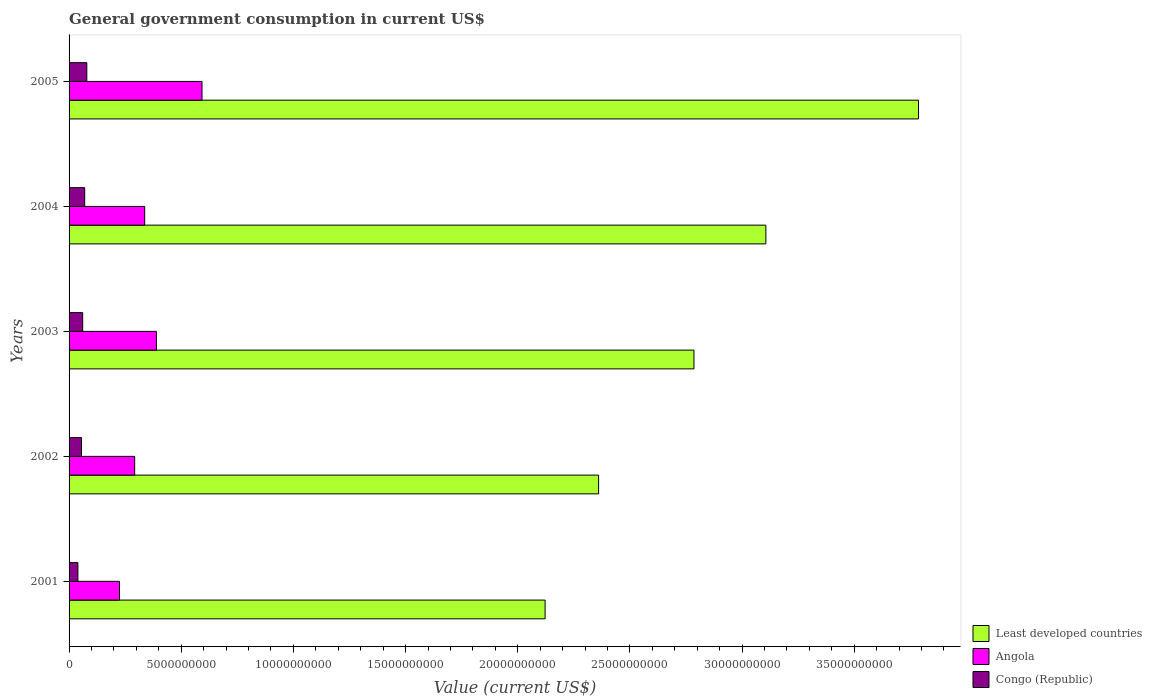How many different coloured bars are there?
Make the answer very short. 3. How many groups of bars are there?
Keep it short and to the point. 5. Are the number of bars per tick equal to the number of legend labels?
Keep it short and to the point. Yes. What is the government conusmption in Least developed countries in 2001?
Offer a terse response. 2.12e+1. Across all years, what is the maximum government conusmption in Congo (Republic)?
Provide a succinct answer. 7.91e+08. Across all years, what is the minimum government conusmption in Congo (Republic)?
Provide a succinct answer. 3.94e+08. In which year was the government conusmption in Least developed countries maximum?
Ensure brevity in your answer.  2005. What is the total government conusmption in Least developed countries in the graph?
Keep it short and to the point. 1.42e+11. What is the difference between the government conusmption in Congo (Republic) in 2001 and that in 2003?
Offer a terse response. -2.13e+08. What is the difference between the government conusmption in Angola in 2004 and the government conusmption in Congo (Republic) in 2003?
Offer a terse response. 2.76e+09. What is the average government conusmption in Least developed countries per year?
Provide a succinct answer. 2.83e+1. In the year 2002, what is the difference between the government conusmption in Congo (Republic) and government conusmption in Least developed countries?
Provide a short and direct response. -2.31e+1. What is the ratio of the government conusmption in Angola in 2003 to that in 2005?
Your answer should be compact. 0.66. Is the government conusmption in Least developed countries in 2003 less than that in 2005?
Your response must be concise. Yes. What is the difference between the highest and the second highest government conusmption in Angola?
Your answer should be very brief. 2.03e+09. What is the difference between the highest and the lowest government conusmption in Angola?
Give a very brief answer. 3.68e+09. What does the 2nd bar from the top in 2001 represents?
Provide a short and direct response. Angola. What does the 1st bar from the bottom in 2005 represents?
Provide a short and direct response. Least developed countries. How many years are there in the graph?
Provide a short and direct response. 5. Where does the legend appear in the graph?
Offer a terse response. Bottom right. How many legend labels are there?
Offer a terse response. 3. How are the legend labels stacked?
Ensure brevity in your answer.  Vertical. What is the title of the graph?
Give a very brief answer. General government consumption in current US$. Does "Turkey" appear as one of the legend labels in the graph?
Offer a terse response. No. What is the label or title of the X-axis?
Your response must be concise. Value (current US$). What is the label or title of the Y-axis?
Provide a short and direct response. Years. What is the Value (current US$) in Least developed countries in 2001?
Make the answer very short. 2.12e+1. What is the Value (current US$) of Angola in 2001?
Give a very brief answer. 2.25e+09. What is the Value (current US$) of Congo (Republic) in 2001?
Your answer should be very brief. 3.94e+08. What is the Value (current US$) in Least developed countries in 2002?
Make the answer very short. 2.36e+1. What is the Value (current US$) in Angola in 2002?
Give a very brief answer. 2.92e+09. What is the Value (current US$) in Congo (Republic) in 2002?
Provide a succinct answer. 5.54e+08. What is the Value (current US$) in Least developed countries in 2003?
Provide a succinct answer. 2.79e+1. What is the Value (current US$) in Angola in 2003?
Keep it short and to the point. 3.89e+09. What is the Value (current US$) in Congo (Republic) in 2003?
Offer a terse response. 6.07e+08. What is the Value (current US$) in Least developed countries in 2004?
Offer a very short reply. 3.11e+1. What is the Value (current US$) in Angola in 2004?
Ensure brevity in your answer.  3.37e+09. What is the Value (current US$) in Congo (Republic) in 2004?
Make the answer very short. 6.96e+08. What is the Value (current US$) in Least developed countries in 2005?
Provide a short and direct response. 3.79e+1. What is the Value (current US$) of Angola in 2005?
Your answer should be compact. 5.93e+09. What is the Value (current US$) of Congo (Republic) in 2005?
Provide a short and direct response. 7.91e+08. Across all years, what is the maximum Value (current US$) of Least developed countries?
Provide a succinct answer. 3.79e+1. Across all years, what is the maximum Value (current US$) of Angola?
Keep it short and to the point. 5.93e+09. Across all years, what is the maximum Value (current US$) in Congo (Republic)?
Provide a succinct answer. 7.91e+08. Across all years, what is the minimum Value (current US$) in Least developed countries?
Ensure brevity in your answer.  2.12e+1. Across all years, what is the minimum Value (current US$) in Angola?
Keep it short and to the point. 2.25e+09. Across all years, what is the minimum Value (current US$) of Congo (Republic)?
Offer a terse response. 3.94e+08. What is the total Value (current US$) of Least developed countries in the graph?
Offer a terse response. 1.42e+11. What is the total Value (current US$) of Angola in the graph?
Your answer should be very brief. 1.84e+1. What is the total Value (current US$) in Congo (Republic) in the graph?
Offer a very short reply. 3.04e+09. What is the difference between the Value (current US$) of Least developed countries in 2001 and that in 2002?
Ensure brevity in your answer.  -2.38e+09. What is the difference between the Value (current US$) in Angola in 2001 and that in 2002?
Your answer should be very brief. -6.76e+08. What is the difference between the Value (current US$) in Congo (Republic) in 2001 and that in 2002?
Your answer should be very brief. -1.61e+08. What is the difference between the Value (current US$) in Least developed countries in 2001 and that in 2003?
Offer a very short reply. -6.64e+09. What is the difference between the Value (current US$) of Angola in 2001 and that in 2003?
Your answer should be very brief. -1.65e+09. What is the difference between the Value (current US$) of Congo (Republic) in 2001 and that in 2003?
Offer a terse response. -2.13e+08. What is the difference between the Value (current US$) in Least developed countries in 2001 and that in 2004?
Ensure brevity in your answer.  -9.84e+09. What is the difference between the Value (current US$) of Angola in 2001 and that in 2004?
Your answer should be compact. -1.12e+09. What is the difference between the Value (current US$) of Congo (Republic) in 2001 and that in 2004?
Provide a succinct answer. -3.02e+08. What is the difference between the Value (current US$) of Least developed countries in 2001 and that in 2005?
Keep it short and to the point. -1.66e+1. What is the difference between the Value (current US$) in Angola in 2001 and that in 2005?
Keep it short and to the point. -3.68e+09. What is the difference between the Value (current US$) in Congo (Republic) in 2001 and that in 2005?
Provide a short and direct response. -3.97e+08. What is the difference between the Value (current US$) of Least developed countries in 2002 and that in 2003?
Your answer should be very brief. -4.25e+09. What is the difference between the Value (current US$) of Angola in 2002 and that in 2003?
Provide a succinct answer. -9.69e+08. What is the difference between the Value (current US$) in Congo (Republic) in 2002 and that in 2003?
Your response must be concise. -5.25e+07. What is the difference between the Value (current US$) of Least developed countries in 2002 and that in 2004?
Provide a succinct answer. -7.46e+09. What is the difference between the Value (current US$) in Angola in 2002 and that in 2004?
Ensure brevity in your answer.  -4.47e+08. What is the difference between the Value (current US$) of Congo (Republic) in 2002 and that in 2004?
Offer a very short reply. -1.42e+08. What is the difference between the Value (current US$) of Least developed countries in 2002 and that in 2005?
Ensure brevity in your answer.  -1.43e+1. What is the difference between the Value (current US$) in Angola in 2002 and that in 2005?
Offer a terse response. -3.00e+09. What is the difference between the Value (current US$) of Congo (Republic) in 2002 and that in 2005?
Your answer should be very brief. -2.37e+08. What is the difference between the Value (current US$) in Least developed countries in 2003 and that in 2004?
Your answer should be very brief. -3.21e+09. What is the difference between the Value (current US$) of Angola in 2003 and that in 2004?
Offer a very short reply. 5.22e+08. What is the difference between the Value (current US$) of Congo (Republic) in 2003 and that in 2004?
Give a very brief answer. -8.92e+07. What is the difference between the Value (current US$) of Least developed countries in 2003 and that in 2005?
Ensure brevity in your answer.  -1.00e+1. What is the difference between the Value (current US$) in Angola in 2003 and that in 2005?
Keep it short and to the point. -2.03e+09. What is the difference between the Value (current US$) in Congo (Republic) in 2003 and that in 2005?
Give a very brief answer. -1.84e+08. What is the difference between the Value (current US$) of Least developed countries in 2004 and that in 2005?
Offer a terse response. -6.80e+09. What is the difference between the Value (current US$) of Angola in 2004 and that in 2005?
Make the answer very short. -2.56e+09. What is the difference between the Value (current US$) of Congo (Republic) in 2004 and that in 2005?
Your answer should be compact. -9.49e+07. What is the difference between the Value (current US$) of Least developed countries in 2001 and the Value (current US$) of Angola in 2002?
Give a very brief answer. 1.83e+1. What is the difference between the Value (current US$) of Least developed countries in 2001 and the Value (current US$) of Congo (Republic) in 2002?
Your answer should be compact. 2.07e+1. What is the difference between the Value (current US$) of Angola in 2001 and the Value (current US$) of Congo (Republic) in 2002?
Your answer should be compact. 1.69e+09. What is the difference between the Value (current US$) in Least developed countries in 2001 and the Value (current US$) in Angola in 2003?
Offer a very short reply. 1.73e+1. What is the difference between the Value (current US$) of Least developed countries in 2001 and the Value (current US$) of Congo (Republic) in 2003?
Your response must be concise. 2.06e+1. What is the difference between the Value (current US$) in Angola in 2001 and the Value (current US$) in Congo (Republic) in 2003?
Your response must be concise. 1.64e+09. What is the difference between the Value (current US$) in Least developed countries in 2001 and the Value (current US$) in Angola in 2004?
Make the answer very short. 1.78e+1. What is the difference between the Value (current US$) of Least developed countries in 2001 and the Value (current US$) of Congo (Republic) in 2004?
Make the answer very short. 2.05e+1. What is the difference between the Value (current US$) of Angola in 2001 and the Value (current US$) of Congo (Republic) in 2004?
Your answer should be very brief. 1.55e+09. What is the difference between the Value (current US$) of Least developed countries in 2001 and the Value (current US$) of Angola in 2005?
Ensure brevity in your answer.  1.53e+1. What is the difference between the Value (current US$) of Least developed countries in 2001 and the Value (current US$) of Congo (Republic) in 2005?
Provide a short and direct response. 2.04e+1. What is the difference between the Value (current US$) of Angola in 2001 and the Value (current US$) of Congo (Republic) in 2005?
Give a very brief answer. 1.46e+09. What is the difference between the Value (current US$) of Least developed countries in 2002 and the Value (current US$) of Angola in 2003?
Your response must be concise. 1.97e+1. What is the difference between the Value (current US$) of Least developed countries in 2002 and the Value (current US$) of Congo (Republic) in 2003?
Offer a terse response. 2.30e+1. What is the difference between the Value (current US$) of Angola in 2002 and the Value (current US$) of Congo (Republic) in 2003?
Give a very brief answer. 2.32e+09. What is the difference between the Value (current US$) of Least developed countries in 2002 and the Value (current US$) of Angola in 2004?
Your answer should be very brief. 2.02e+1. What is the difference between the Value (current US$) in Least developed countries in 2002 and the Value (current US$) in Congo (Republic) in 2004?
Keep it short and to the point. 2.29e+1. What is the difference between the Value (current US$) in Angola in 2002 and the Value (current US$) in Congo (Republic) in 2004?
Offer a very short reply. 2.23e+09. What is the difference between the Value (current US$) of Least developed countries in 2002 and the Value (current US$) of Angola in 2005?
Provide a succinct answer. 1.77e+1. What is the difference between the Value (current US$) of Least developed countries in 2002 and the Value (current US$) of Congo (Republic) in 2005?
Your answer should be very brief. 2.28e+1. What is the difference between the Value (current US$) of Angola in 2002 and the Value (current US$) of Congo (Republic) in 2005?
Your answer should be very brief. 2.13e+09. What is the difference between the Value (current US$) in Least developed countries in 2003 and the Value (current US$) in Angola in 2004?
Your response must be concise. 2.45e+1. What is the difference between the Value (current US$) of Least developed countries in 2003 and the Value (current US$) of Congo (Republic) in 2004?
Give a very brief answer. 2.72e+1. What is the difference between the Value (current US$) of Angola in 2003 and the Value (current US$) of Congo (Republic) in 2004?
Ensure brevity in your answer.  3.20e+09. What is the difference between the Value (current US$) in Least developed countries in 2003 and the Value (current US$) in Angola in 2005?
Provide a succinct answer. 2.19e+1. What is the difference between the Value (current US$) of Least developed countries in 2003 and the Value (current US$) of Congo (Republic) in 2005?
Make the answer very short. 2.71e+1. What is the difference between the Value (current US$) of Angola in 2003 and the Value (current US$) of Congo (Republic) in 2005?
Your answer should be compact. 3.10e+09. What is the difference between the Value (current US$) of Least developed countries in 2004 and the Value (current US$) of Angola in 2005?
Ensure brevity in your answer.  2.51e+1. What is the difference between the Value (current US$) of Least developed countries in 2004 and the Value (current US$) of Congo (Republic) in 2005?
Keep it short and to the point. 3.03e+1. What is the difference between the Value (current US$) of Angola in 2004 and the Value (current US$) of Congo (Republic) in 2005?
Ensure brevity in your answer.  2.58e+09. What is the average Value (current US$) in Least developed countries per year?
Ensure brevity in your answer.  2.83e+1. What is the average Value (current US$) in Angola per year?
Ensure brevity in your answer.  3.67e+09. What is the average Value (current US$) of Congo (Republic) per year?
Offer a terse response. 6.08e+08. In the year 2001, what is the difference between the Value (current US$) of Least developed countries and Value (current US$) of Angola?
Ensure brevity in your answer.  1.90e+1. In the year 2001, what is the difference between the Value (current US$) of Least developed countries and Value (current US$) of Congo (Republic)?
Offer a terse response. 2.08e+1. In the year 2001, what is the difference between the Value (current US$) of Angola and Value (current US$) of Congo (Republic)?
Keep it short and to the point. 1.85e+09. In the year 2002, what is the difference between the Value (current US$) of Least developed countries and Value (current US$) of Angola?
Your answer should be compact. 2.07e+1. In the year 2002, what is the difference between the Value (current US$) in Least developed countries and Value (current US$) in Congo (Republic)?
Ensure brevity in your answer.  2.31e+1. In the year 2002, what is the difference between the Value (current US$) in Angola and Value (current US$) in Congo (Republic)?
Provide a short and direct response. 2.37e+09. In the year 2003, what is the difference between the Value (current US$) of Least developed countries and Value (current US$) of Angola?
Offer a terse response. 2.40e+1. In the year 2003, what is the difference between the Value (current US$) in Least developed countries and Value (current US$) in Congo (Republic)?
Your answer should be very brief. 2.72e+1. In the year 2003, what is the difference between the Value (current US$) of Angola and Value (current US$) of Congo (Republic)?
Offer a terse response. 3.29e+09. In the year 2004, what is the difference between the Value (current US$) in Least developed countries and Value (current US$) in Angola?
Your answer should be compact. 2.77e+1. In the year 2004, what is the difference between the Value (current US$) in Least developed countries and Value (current US$) in Congo (Republic)?
Your response must be concise. 3.04e+1. In the year 2004, what is the difference between the Value (current US$) of Angola and Value (current US$) of Congo (Republic)?
Provide a short and direct response. 2.67e+09. In the year 2005, what is the difference between the Value (current US$) in Least developed countries and Value (current US$) in Angola?
Offer a terse response. 3.19e+1. In the year 2005, what is the difference between the Value (current US$) in Least developed countries and Value (current US$) in Congo (Republic)?
Ensure brevity in your answer.  3.71e+1. In the year 2005, what is the difference between the Value (current US$) of Angola and Value (current US$) of Congo (Republic)?
Your response must be concise. 5.14e+09. What is the ratio of the Value (current US$) in Least developed countries in 2001 to that in 2002?
Provide a short and direct response. 0.9. What is the ratio of the Value (current US$) of Angola in 2001 to that in 2002?
Your answer should be very brief. 0.77. What is the ratio of the Value (current US$) of Congo (Republic) in 2001 to that in 2002?
Your response must be concise. 0.71. What is the ratio of the Value (current US$) in Least developed countries in 2001 to that in 2003?
Offer a very short reply. 0.76. What is the ratio of the Value (current US$) of Angola in 2001 to that in 2003?
Your response must be concise. 0.58. What is the ratio of the Value (current US$) of Congo (Republic) in 2001 to that in 2003?
Keep it short and to the point. 0.65. What is the ratio of the Value (current US$) of Least developed countries in 2001 to that in 2004?
Your answer should be compact. 0.68. What is the ratio of the Value (current US$) in Angola in 2001 to that in 2004?
Provide a short and direct response. 0.67. What is the ratio of the Value (current US$) in Congo (Republic) in 2001 to that in 2004?
Your response must be concise. 0.57. What is the ratio of the Value (current US$) of Least developed countries in 2001 to that in 2005?
Keep it short and to the point. 0.56. What is the ratio of the Value (current US$) in Angola in 2001 to that in 2005?
Offer a very short reply. 0.38. What is the ratio of the Value (current US$) in Congo (Republic) in 2001 to that in 2005?
Keep it short and to the point. 0.5. What is the ratio of the Value (current US$) in Least developed countries in 2002 to that in 2003?
Offer a terse response. 0.85. What is the ratio of the Value (current US$) of Angola in 2002 to that in 2003?
Offer a very short reply. 0.75. What is the ratio of the Value (current US$) of Congo (Republic) in 2002 to that in 2003?
Offer a terse response. 0.91. What is the ratio of the Value (current US$) in Least developed countries in 2002 to that in 2004?
Provide a succinct answer. 0.76. What is the ratio of the Value (current US$) in Angola in 2002 to that in 2004?
Provide a short and direct response. 0.87. What is the ratio of the Value (current US$) in Congo (Republic) in 2002 to that in 2004?
Ensure brevity in your answer.  0.8. What is the ratio of the Value (current US$) of Least developed countries in 2002 to that in 2005?
Make the answer very short. 0.62. What is the ratio of the Value (current US$) of Angola in 2002 to that in 2005?
Give a very brief answer. 0.49. What is the ratio of the Value (current US$) of Congo (Republic) in 2002 to that in 2005?
Provide a short and direct response. 0.7. What is the ratio of the Value (current US$) in Least developed countries in 2003 to that in 2004?
Keep it short and to the point. 0.9. What is the ratio of the Value (current US$) in Angola in 2003 to that in 2004?
Your answer should be compact. 1.15. What is the ratio of the Value (current US$) of Congo (Republic) in 2003 to that in 2004?
Give a very brief answer. 0.87. What is the ratio of the Value (current US$) of Least developed countries in 2003 to that in 2005?
Offer a terse response. 0.74. What is the ratio of the Value (current US$) of Angola in 2003 to that in 2005?
Keep it short and to the point. 0.66. What is the ratio of the Value (current US$) of Congo (Republic) in 2003 to that in 2005?
Your answer should be compact. 0.77. What is the ratio of the Value (current US$) in Least developed countries in 2004 to that in 2005?
Your response must be concise. 0.82. What is the ratio of the Value (current US$) of Angola in 2004 to that in 2005?
Offer a very short reply. 0.57. What is the ratio of the Value (current US$) of Congo (Republic) in 2004 to that in 2005?
Provide a short and direct response. 0.88. What is the difference between the highest and the second highest Value (current US$) in Least developed countries?
Provide a short and direct response. 6.80e+09. What is the difference between the highest and the second highest Value (current US$) in Angola?
Your response must be concise. 2.03e+09. What is the difference between the highest and the second highest Value (current US$) of Congo (Republic)?
Your answer should be compact. 9.49e+07. What is the difference between the highest and the lowest Value (current US$) of Least developed countries?
Provide a short and direct response. 1.66e+1. What is the difference between the highest and the lowest Value (current US$) in Angola?
Your response must be concise. 3.68e+09. What is the difference between the highest and the lowest Value (current US$) in Congo (Republic)?
Offer a very short reply. 3.97e+08. 